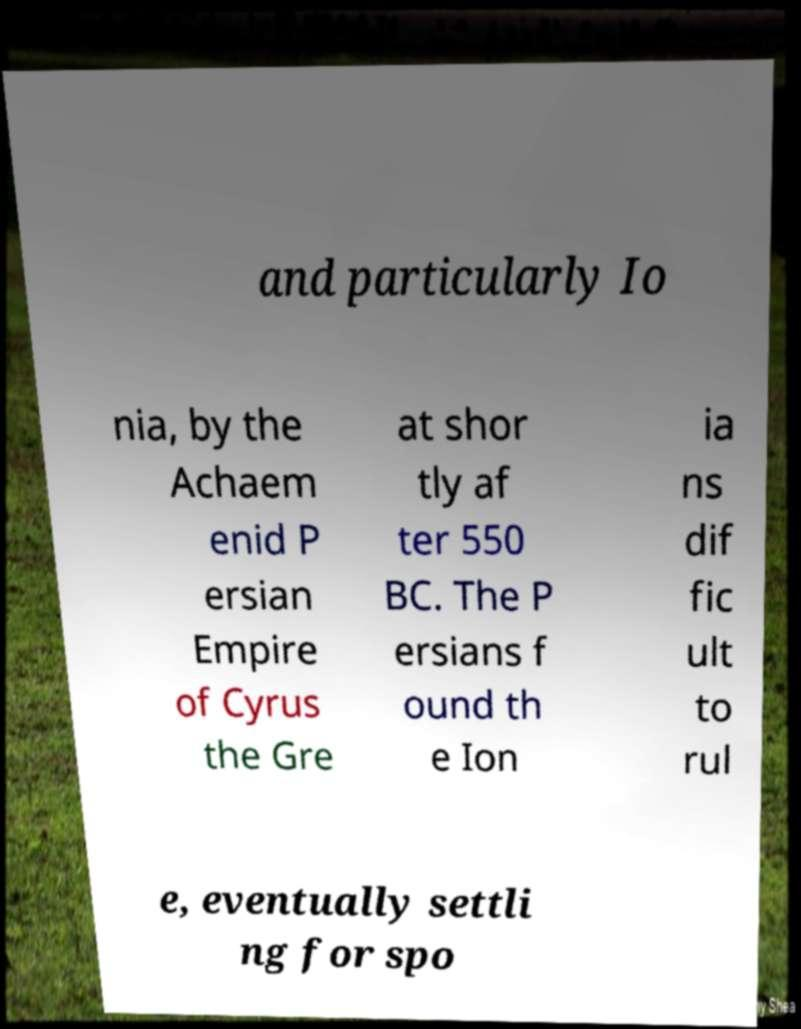Could you assist in decoding the text presented in this image and type it out clearly? and particularly Io nia, by the Achaem enid P ersian Empire of Cyrus the Gre at shor tly af ter 550 BC. The P ersians f ound th e Ion ia ns dif fic ult to rul e, eventually settli ng for spo 